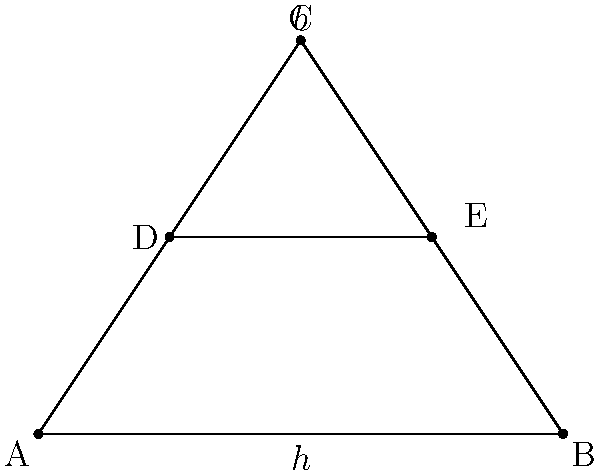In the construction of muqarnas, the proportions of triangular elements are crucial. Consider the triangle ABC in the diagram, which represents a basic muqarnas unit. If the base of the triangle (AB) is 4 units and the height (h) is 3 units, what is the length of DE, where D and E are the midpoints of AC and BC respectively? To solve this problem, we'll follow these steps:

1) First, we need to recognize that DE is parallel to AB and cuts the triangle at the midpoints of the sides.

2) In any triangle, a line segment connecting the midpoints of two sides is parallel to the third side and half the length of the third side.

3) Therefore, DE is parallel to AB and its length is half of AB.

4) We are given that AB = 4 units.

5) So, the length of DE = $\frac{1}{2} \times AB = \frac{1}{2} \times 4 = 2$ units.

This principle is often used in muqarnas design to create harmonious proportions and structural stability. The ratio of 1:2 between the midline and the base is a fundamental geometric relationship that contributes to the aesthetic and structural integrity of muqarnas vaulting.
Answer: 2 units 